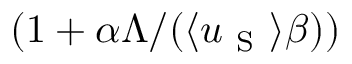<formula> <loc_0><loc_0><loc_500><loc_500>( 1 + \alpha \Lambda / ( \langle u _ { S } \rangle \beta ) )</formula> 